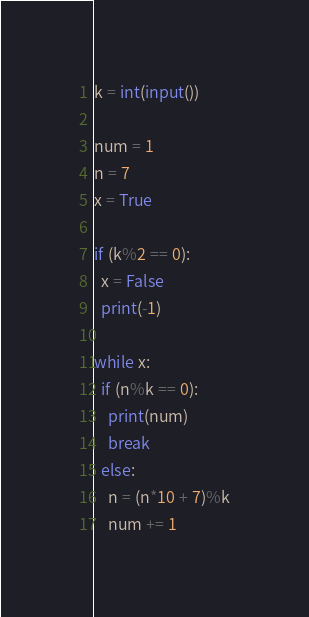Convert code to text. <code><loc_0><loc_0><loc_500><loc_500><_Python_>k = int(input())

num = 1 
n = 7
x = True
 
if (k%2 == 0):
  x = False
  print(-1)

while x:
  if (n%k == 0):
    print(num)
    break
  else:
    n = (n*10 + 7)%k
    num += 1
</code> 